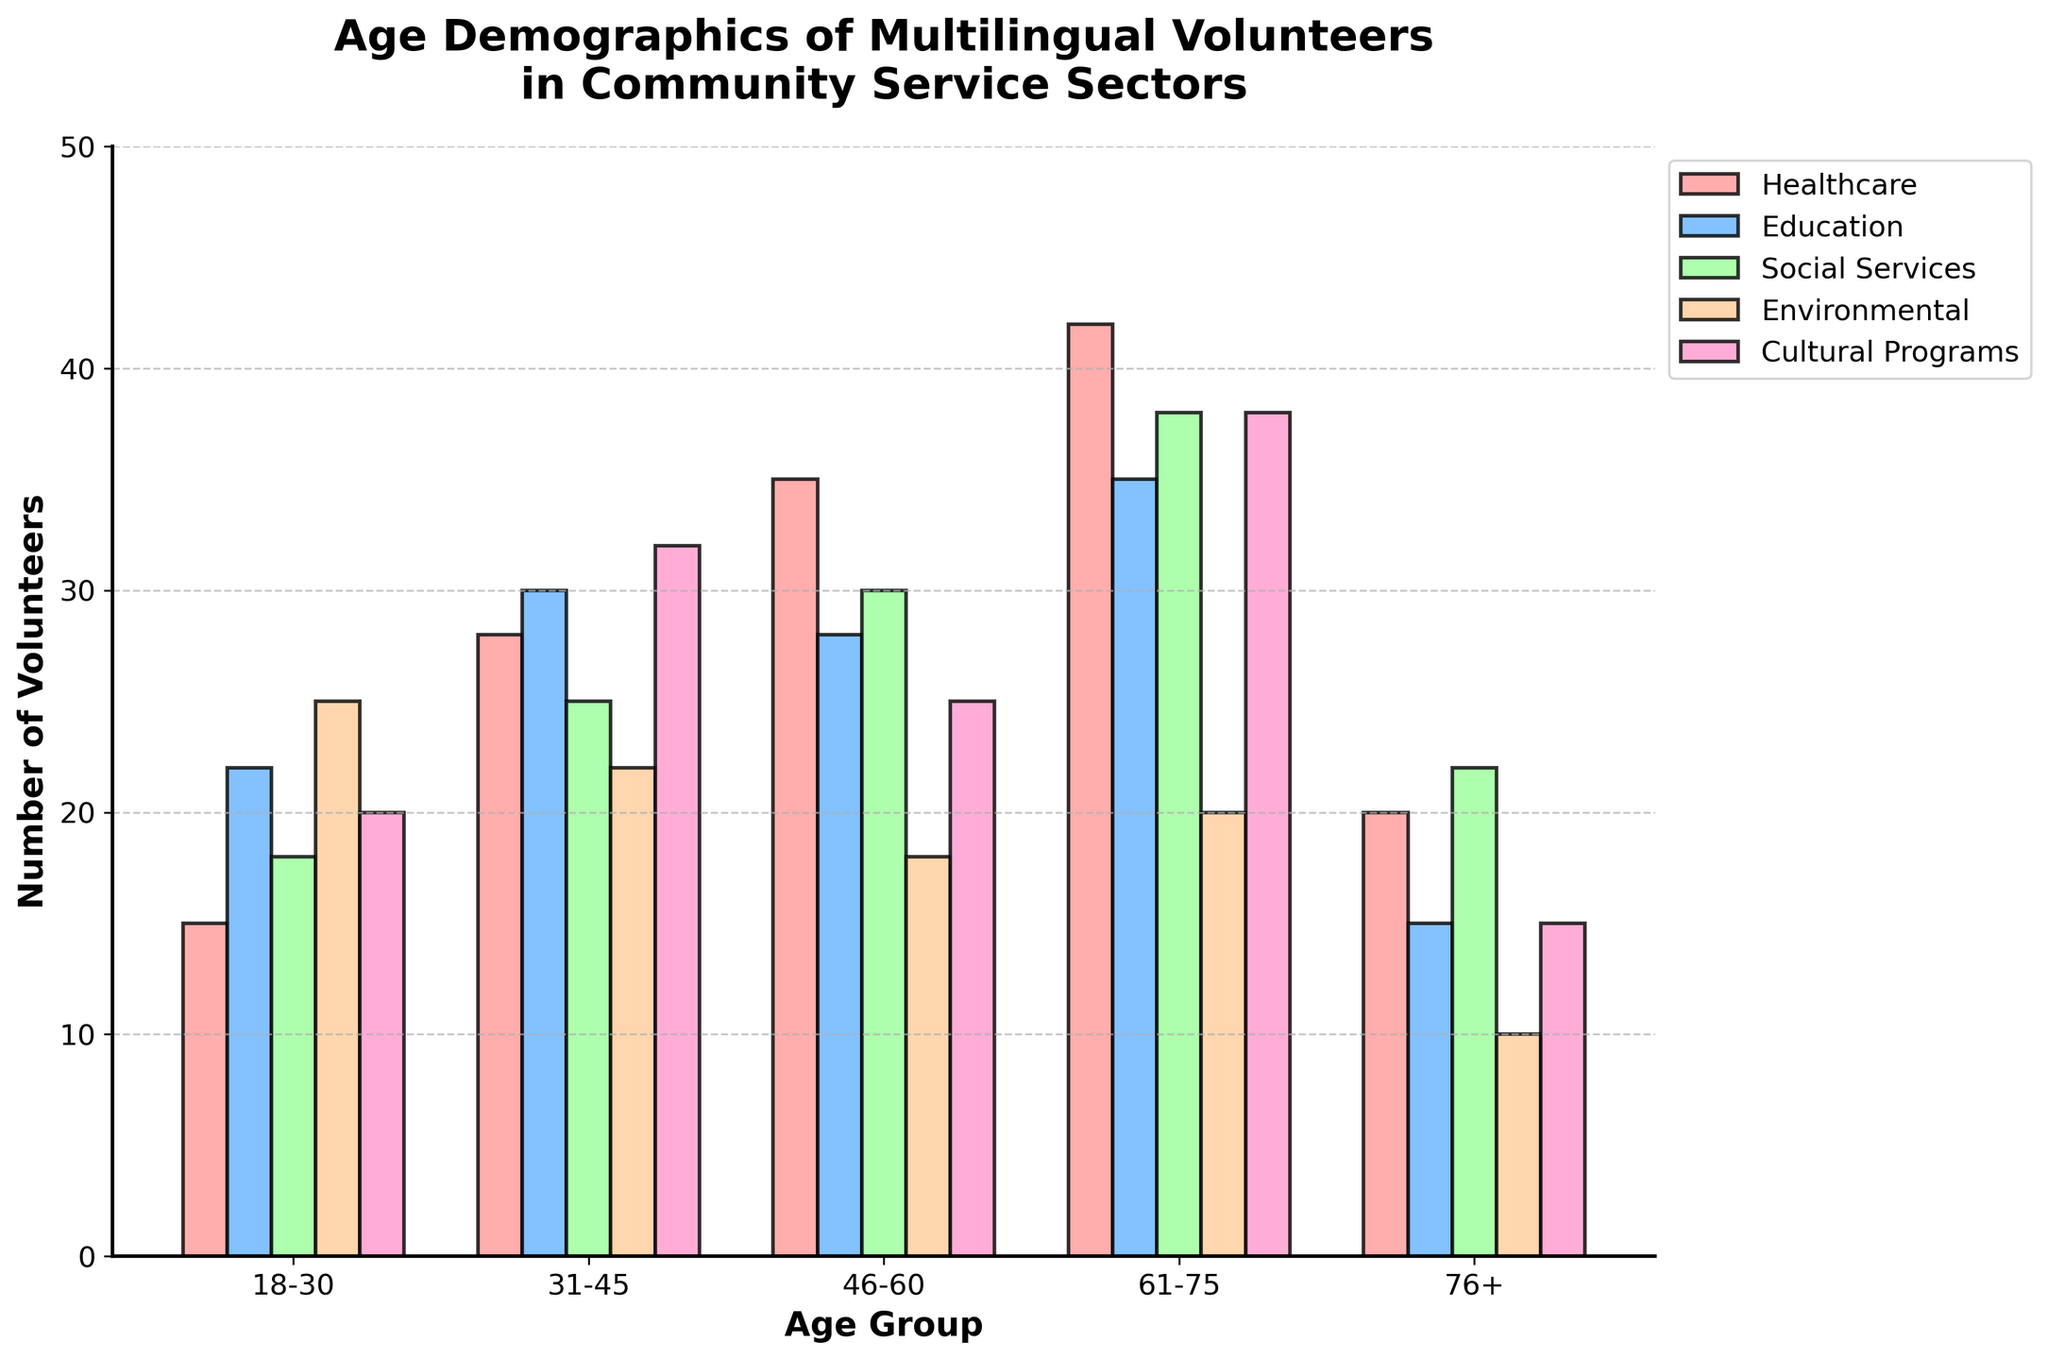Which age group has the highest number of volunteers in the Healthcare sector? By examining the bars representing each age group in the Healthcare sector, you can see that the 61-75 age group has the highest bar.
Answer: 61-75 Which sector has the least number of volunteers aged 76+? Find the bars for the 76+ age group and compare their heights across sectors. The Environmental sector has the shortest bar.
Answer: Environmental What is the total number of volunteers aged 18-30 across all sectors? Sum the values of the 18-30 age group in each sector: 15 (Healthcare) + 22 (Education) + 18 (Social Services) + 25 (Environmental) + 20 (Cultural Programs) = 100.
Answer: 100 Which sector has the most balanced volunteer distribution across all age groups? Compare the heights of bars within each sector; the Cultural Programs sector appears to have the most consistent heights across age groups.
Answer: Cultural Programs What is the difference between the number of volunteers aged 31-45 and those aged 46-60 in the Social Services sector? Subtract the number of volunteers aged 46-60 (30) from those aged 31-45 (25) in the Social Services sector: 25 - 30 = -5.
Answer: -5 Which age group contributes the most to the Social Services sector? Identify the age group with the tallest bar in the Social Services sector; the 61-75 age group has the tallest bar.
Answer: 61-75 What is the average number of volunteers in the Education sector across all age groups? Sum the values of the Education sector and divide by the number of age groups: (22 + 30 + 28 + 35 + 15) / 5 = 130 / 5 = 26.
Answer: 26 By how much does the number of volunteers aged 61-75 in Cultural Programs exceed those in Healthcare? Compare the number of volunteers aged 61-75 in Cultural Programs (38) and Healthcare (42), and find the difference: 38 - 42 = -4.
Answer: -4 Is the number of volunteers aged 46-60 in the Environmental sector higher or lower than those aged 46-60 in the Healthcare sector? Compare the respective values: 18 in Environmental vs. 35 in Healthcare.
Answer: Lower How many more volunteers are in the oldest age group (76+) in Social Services compared to the Environmental sector? Subtract the number of volunteers aged 76+ in the Environmental sector (10) from those in Social Services (22): 22 - 10 = 12.
Answer: 12 